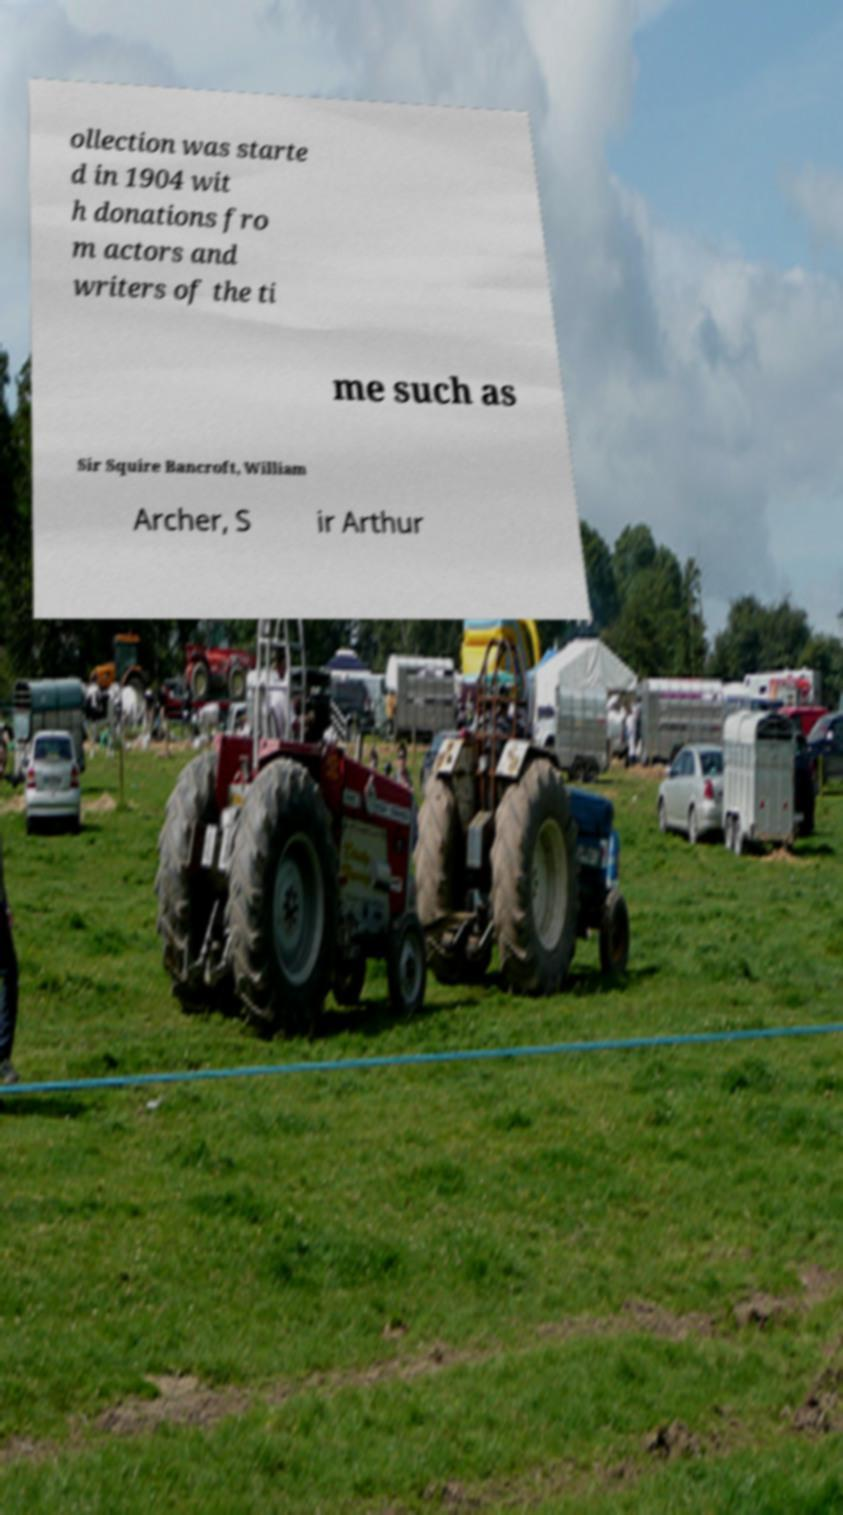I need the written content from this picture converted into text. Can you do that? ollection was starte d in 1904 wit h donations fro m actors and writers of the ti me such as Sir Squire Bancroft, William Archer, S ir Arthur 